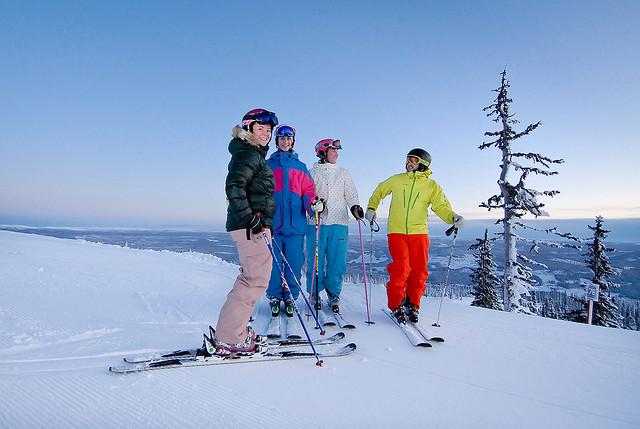Which color is dominant?
Give a very brief answer. White. Is the woman's outfit coordinated?
Concise answer only. Yes. Has the snow been plowed/smoothed over?
Be succinct. Yes. How many people are there?
Be succinct. 4. Are these people currently moving at a high speed?
Keep it brief. No. Where is the girl with the pink snow pants?
Give a very brief answer. Left. What color are her pants?
Concise answer only. Pink. How are the visibility conditions?
Quick response, please. Clear. Why do they wear protection on their heads?
Keep it brief. Yes. How many people are here?
Be succinct. 4. Are these skiers wearing matching coats?
Give a very brief answer. No. 